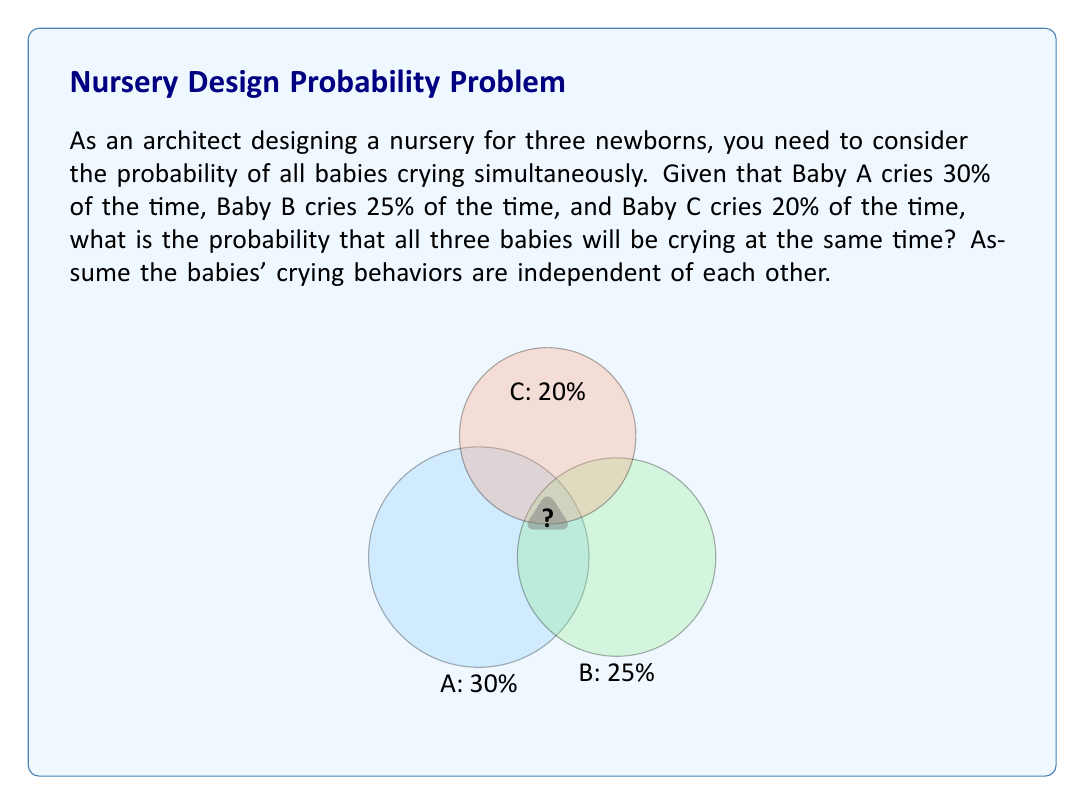Can you answer this question? To solve this problem, we'll use the concept of independent events in probability theory. The probability of all three events occurring simultaneously is the product of their individual probabilities.

Step 1: Convert the given percentages to probabilities.
Baby A: 30% = 0.30
Baby B: 25% = 0.25
Baby C: 20% = 0.20

Step 2: Calculate the probability of all three babies crying simultaneously.
Let $P(A)$, $P(B)$, and $P(C)$ be the probabilities of babies A, B, and C crying, respectively.

The probability of all three crying simultaneously is:

$$ P(A \cap B \cap C) = P(A) \times P(B) \times P(C) $$

Step 3: Substitute the values and calculate.

$$ P(A \cap B \cap C) = 0.30 \times 0.25 \times 0.20 $$

$$ P(A \cap B \cap C) = 0.015 $$

Step 4: Convert the result to a percentage.

$$ 0.015 \times 100\% = 1.5\% $$

Therefore, the probability of all three babies crying simultaneously is 1.5% or 0.015.
Answer: 1.5% or 0.015 